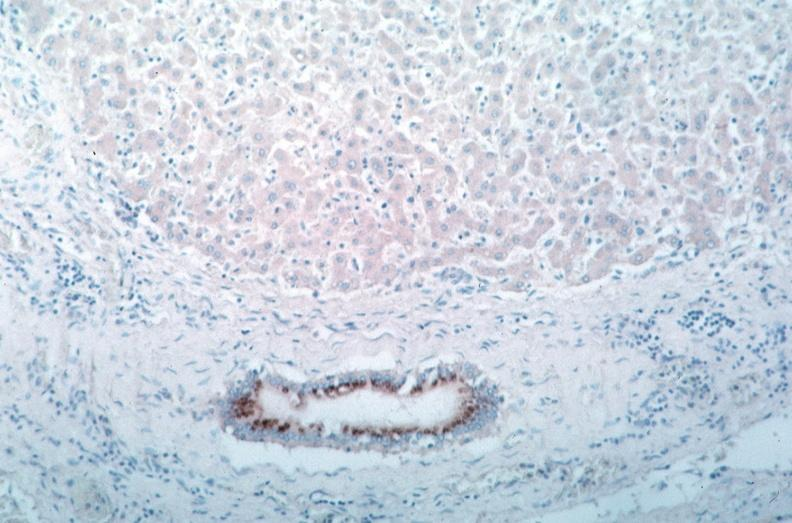where is this from?
Answer the question using a single word or phrase. Vasculature 